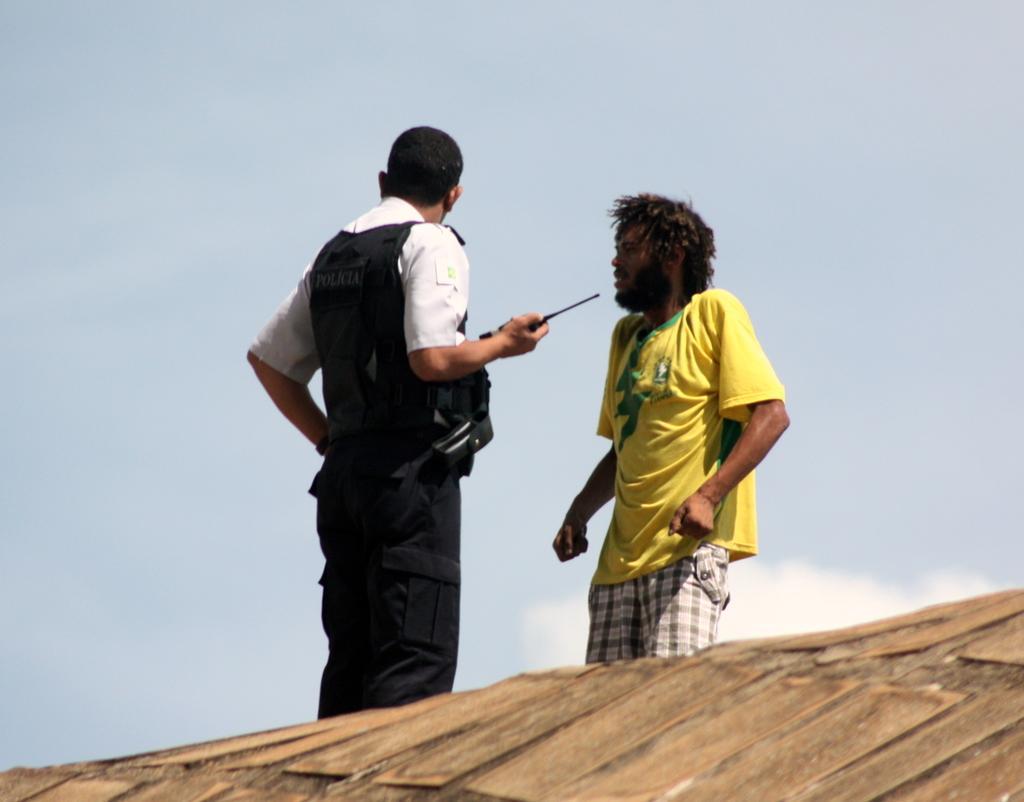How would you summarize this image in a sentence or two? In this image we can see two people standing. At the bottom of the image there is surface. In the background of the image there is sky and clouds. 